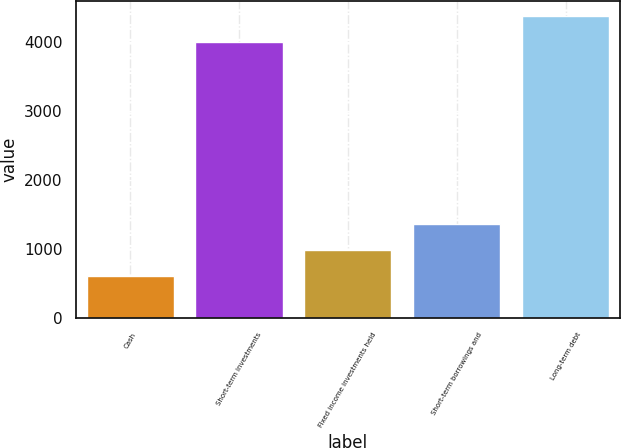<chart> <loc_0><loc_0><loc_500><loc_500><bar_chart><fcel>Cash<fcel>Short-term investments<fcel>Fixed income investments held<fcel>Short-term borrowings and<fcel>Long-term debt<nl><fcel>617<fcel>3999<fcel>990.8<fcel>1364.6<fcel>4372.8<nl></chart> 